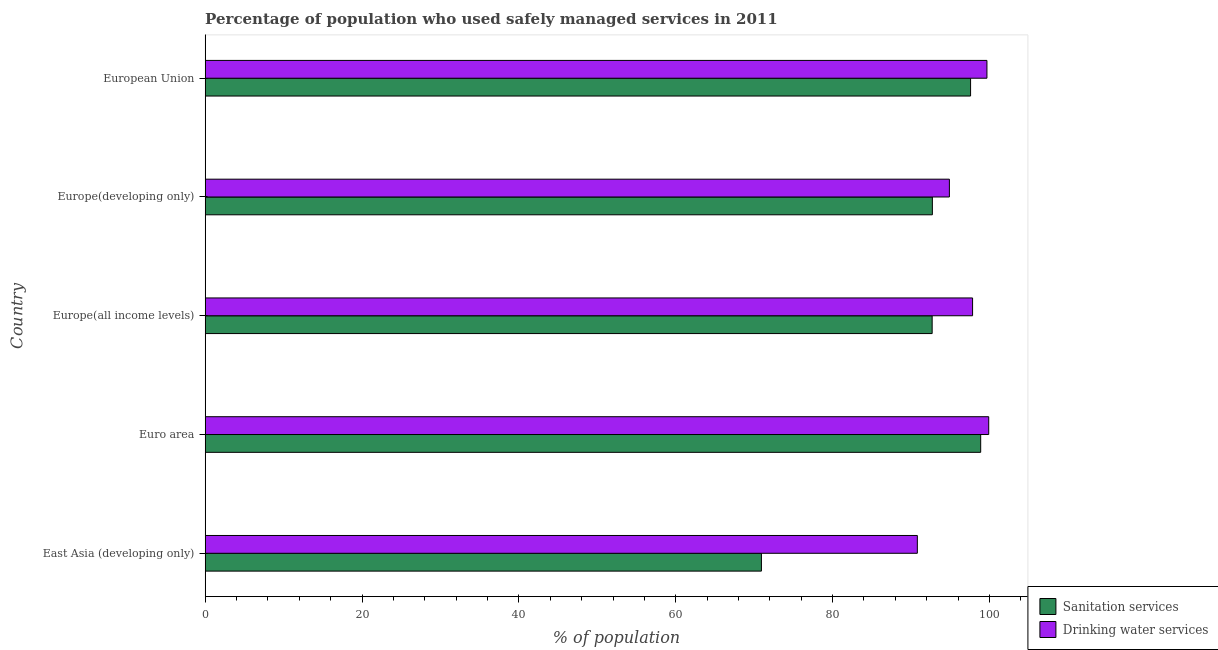How many different coloured bars are there?
Your answer should be compact. 2. How many groups of bars are there?
Make the answer very short. 5. Are the number of bars per tick equal to the number of legend labels?
Provide a short and direct response. Yes. How many bars are there on the 5th tick from the bottom?
Provide a succinct answer. 2. What is the label of the 2nd group of bars from the top?
Offer a very short reply. Europe(developing only). In how many cases, is the number of bars for a given country not equal to the number of legend labels?
Provide a short and direct response. 0. What is the percentage of population who used drinking water services in East Asia (developing only)?
Give a very brief answer. 90.81. Across all countries, what is the maximum percentage of population who used drinking water services?
Your response must be concise. 99.91. Across all countries, what is the minimum percentage of population who used drinking water services?
Make the answer very short. 90.81. In which country was the percentage of population who used sanitation services maximum?
Your response must be concise. Euro area. In which country was the percentage of population who used sanitation services minimum?
Your response must be concise. East Asia (developing only). What is the total percentage of population who used sanitation services in the graph?
Your answer should be very brief. 452.82. What is the difference between the percentage of population who used sanitation services in East Asia (developing only) and that in European Union?
Your answer should be very brief. -26.67. What is the difference between the percentage of population who used sanitation services in Europe(developing only) and the percentage of population who used drinking water services in East Asia (developing only)?
Offer a terse response. 1.92. What is the average percentage of population who used sanitation services per country?
Give a very brief answer. 90.56. What is the difference between the percentage of population who used sanitation services and percentage of population who used drinking water services in European Union?
Provide a short and direct response. -2.09. In how many countries, is the percentage of population who used drinking water services greater than 12 %?
Your answer should be compact. 5. What is the ratio of the percentage of population who used sanitation services in East Asia (developing only) to that in Europe(all income levels)?
Offer a very short reply. 0.77. Is the percentage of population who used drinking water services in Europe(all income levels) less than that in European Union?
Keep it short and to the point. Yes. What is the difference between the highest and the second highest percentage of population who used sanitation services?
Your answer should be compact. 1.29. What is the difference between the highest and the lowest percentage of population who used sanitation services?
Keep it short and to the point. 27.96. In how many countries, is the percentage of population who used sanitation services greater than the average percentage of population who used sanitation services taken over all countries?
Provide a short and direct response. 4. Is the sum of the percentage of population who used sanitation services in Euro area and Europe(developing only) greater than the maximum percentage of population who used drinking water services across all countries?
Ensure brevity in your answer.  Yes. What does the 1st bar from the top in East Asia (developing only) represents?
Your answer should be compact. Drinking water services. What does the 2nd bar from the bottom in Europe(developing only) represents?
Ensure brevity in your answer.  Drinking water services. How many bars are there?
Keep it short and to the point. 10. Are all the bars in the graph horizontal?
Offer a very short reply. Yes. How many countries are there in the graph?
Provide a short and direct response. 5. What is the difference between two consecutive major ticks on the X-axis?
Ensure brevity in your answer.  20. Are the values on the major ticks of X-axis written in scientific E-notation?
Make the answer very short. No. Does the graph contain any zero values?
Provide a short and direct response. No. Where does the legend appear in the graph?
Give a very brief answer. Bottom right. What is the title of the graph?
Your response must be concise. Percentage of population who used safely managed services in 2011. What is the label or title of the X-axis?
Provide a short and direct response. % of population. What is the label or title of the Y-axis?
Your response must be concise. Country. What is the % of population in Sanitation services in East Asia (developing only)?
Keep it short and to the point. 70.93. What is the % of population of Drinking water services in East Asia (developing only)?
Provide a short and direct response. 90.81. What is the % of population of Sanitation services in Euro area?
Your answer should be very brief. 98.88. What is the % of population of Drinking water services in Euro area?
Your answer should be very brief. 99.91. What is the % of population of Sanitation services in Europe(all income levels)?
Your answer should be compact. 92.69. What is the % of population in Drinking water services in Europe(all income levels)?
Your answer should be compact. 97.85. What is the % of population in Sanitation services in Europe(developing only)?
Your response must be concise. 92.72. What is the % of population in Drinking water services in Europe(developing only)?
Your response must be concise. 94.89. What is the % of population in Sanitation services in European Union?
Your answer should be compact. 97.59. What is the % of population of Drinking water services in European Union?
Provide a short and direct response. 99.68. Across all countries, what is the maximum % of population of Sanitation services?
Provide a short and direct response. 98.88. Across all countries, what is the maximum % of population in Drinking water services?
Offer a very short reply. 99.91. Across all countries, what is the minimum % of population of Sanitation services?
Your answer should be compact. 70.93. Across all countries, what is the minimum % of population in Drinking water services?
Make the answer very short. 90.81. What is the total % of population in Sanitation services in the graph?
Your response must be concise. 452.82. What is the total % of population in Drinking water services in the graph?
Give a very brief answer. 483.14. What is the difference between the % of population of Sanitation services in East Asia (developing only) and that in Euro area?
Your answer should be compact. -27.96. What is the difference between the % of population of Drinking water services in East Asia (developing only) and that in Euro area?
Keep it short and to the point. -9.1. What is the difference between the % of population in Sanitation services in East Asia (developing only) and that in Europe(all income levels)?
Keep it short and to the point. -21.77. What is the difference between the % of population of Drinking water services in East Asia (developing only) and that in Europe(all income levels)?
Keep it short and to the point. -7.04. What is the difference between the % of population of Sanitation services in East Asia (developing only) and that in Europe(developing only)?
Provide a short and direct response. -21.8. What is the difference between the % of population of Drinking water services in East Asia (developing only) and that in Europe(developing only)?
Provide a succinct answer. -4.09. What is the difference between the % of population in Sanitation services in East Asia (developing only) and that in European Union?
Your answer should be very brief. -26.67. What is the difference between the % of population of Drinking water services in East Asia (developing only) and that in European Union?
Your answer should be very brief. -8.87. What is the difference between the % of population of Sanitation services in Euro area and that in Europe(all income levels)?
Your answer should be very brief. 6.19. What is the difference between the % of population in Drinking water services in Euro area and that in Europe(all income levels)?
Keep it short and to the point. 2.06. What is the difference between the % of population of Sanitation services in Euro area and that in Europe(developing only)?
Give a very brief answer. 6.16. What is the difference between the % of population in Drinking water services in Euro area and that in Europe(developing only)?
Give a very brief answer. 5.02. What is the difference between the % of population of Sanitation services in Euro area and that in European Union?
Keep it short and to the point. 1.29. What is the difference between the % of population of Drinking water services in Euro area and that in European Union?
Your response must be concise. 0.23. What is the difference between the % of population in Sanitation services in Europe(all income levels) and that in Europe(developing only)?
Give a very brief answer. -0.03. What is the difference between the % of population of Drinking water services in Europe(all income levels) and that in Europe(developing only)?
Give a very brief answer. 2.96. What is the difference between the % of population of Sanitation services in Europe(all income levels) and that in European Union?
Your answer should be compact. -4.9. What is the difference between the % of population of Drinking water services in Europe(all income levels) and that in European Union?
Your answer should be compact. -1.83. What is the difference between the % of population in Sanitation services in Europe(developing only) and that in European Union?
Make the answer very short. -4.87. What is the difference between the % of population in Drinking water services in Europe(developing only) and that in European Union?
Give a very brief answer. -4.79. What is the difference between the % of population in Sanitation services in East Asia (developing only) and the % of population in Drinking water services in Euro area?
Offer a very short reply. -28.98. What is the difference between the % of population of Sanitation services in East Asia (developing only) and the % of population of Drinking water services in Europe(all income levels)?
Provide a short and direct response. -26.92. What is the difference between the % of population in Sanitation services in East Asia (developing only) and the % of population in Drinking water services in Europe(developing only)?
Keep it short and to the point. -23.97. What is the difference between the % of population in Sanitation services in East Asia (developing only) and the % of population in Drinking water services in European Union?
Make the answer very short. -28.75. What is the difference between the % of population of Sanitation services in Euro area and the % of population of Drinking water services in Europe(all income levels)?
Make the answer very short. 1.03. What is the difference between the % of population of Sanitation services in Euro area and the % of population of Drinking water services in Europe(developing only)?
Provide a succinct answer. 3.99. What is the difference between the % of population in Sanitation services in Euro area and the % of population in Drinking water services in European Union?
Your response must be concise. -0.8. What is the difference between the % of population of Sanitation services in Europe(all income levels) and the % of population of Drinking water services in Europe(developing only)?
Offer a very short reply. -2.2. What is the difference between the % of population of Sanitation services in Europe(all income levels) and the % of population of Drinking water services in European Union?
Give a very brief answer. -6.99. What is the difference between the % of population in Sanitation services in Europe(developing only) and the % of population in Drinking water services in European Union?
Ensure brevity in your answer.  -6.96. What is the average % of population in Sanitation services per country?
Ensure brevity in your answer.  90.56. What is the average % of population in Drinking water services per country?
Make the answer very short. 96.63. What is the difference between the % of population of Sanitation services and % of population of Drinking water services in East Asia (developing only)?
Offer a very short reply. -19.88. What is the difference between the % of population in Sanitation services and % of population in Drinking water services in Euro area?
Provide a succinct answer. -1.02. What is the difference between the % of population of Sanitation services and % of population of Drinking water services in Europe(all income levels)?
Keep it short and to the point. -5.16. What is the difference between the % of population in Sanitation services and % of population in Drinking water services in Europe(developing only)?
Keep it short and to the point. -2.17. What is the difference between the % of population of Sanitation services and % of population of Drinking water services in European Union?
Offer a terse response. -2.09. What is the ratio of the % of population of Sanitation services in East Asia (developing only) to that in Euro area?
Your answer should be very brief. 0.72. What is the ratio of the % of population of Drinking water services in East Asia (developing only) to that in Euro area?
Provide a short and direct response. 0.91. What is the ratio of the % of population of Sanitation services in East Asia (developing only) to that in Europe(all income levels)?
Your answer should be very brief. 0.77. What is the ratio of the % of population of Drinking water services in East Asia (developing only) to that in Europe(all income levels)?
Your answer should be compact. 0.93. What is the ratio of the % of population of Sanitation services in East Asia (developing only) to that in Europe(developing only)?
Give a very brief answer. 0.76. What is the ratio of the % of population in Drinking water services in East Asia (developing only) to that in Europe(developing only)?
Your response must be concise. 0.96. What is the ratio of the % of population of Sanitation services in East Asia (developing only) to that in European Union?
Offer a very short reply. 0.73. What is the ratio of the % of population in Drinking water services in East Asia (developing only) to that in European Union?
Your response must be concise. 0.91. What is the ratio of the % of population of Sanitation services in Euro area to that in Europe(all income levels)?
Your answer should be very brief. 1.07. What is the ratio of the % of population in Sanitation services in Euro area to that in Europe(developing only)?
Provide a succinct answer. 1.07. What is the ratio of the % of population of Drinking water services in Euro area to that in Europe(developing only)?
Offer a very short reply. 1.05. What is the ratio of the % of population of Sanitation services in Euro area to that in European Union?
Keep it short and to the point. 1.01. What is the ratio of the % of population in Drinking water services in Europe(all income levels) to that in Europe(developing only)?
Your answer should be very brief. 1.03. What is the ratio of the % of population of Sanitation services in Europe(all income levels) to that in European Union?
Make the answer very short. 0.95. What is the ratio of the % of population of Drinking water services in Europe(all income levels) to that in European Union?
Offer a terse response. 0.98. What is the ratio of the % of population of Sanitation services in Europe(developing only) to that in European Union?
Your answer should be compact. 0.95. What is the difference between the highest and the second highest % of population in Sanitation services?
Ensure brevity in your answer.  1.29. What is the difference between the highest and the second highest % of population of Drinking water services?
Your answer should be very brief. 0.23. What is the difference between the highest and the lowest % of population of Sanitation services?
Ensure brevity in your answer.  27.96. What is the difference between the highest and the lowest % of population of Drinking water services?
Keep it short and to the point. 9.1. 